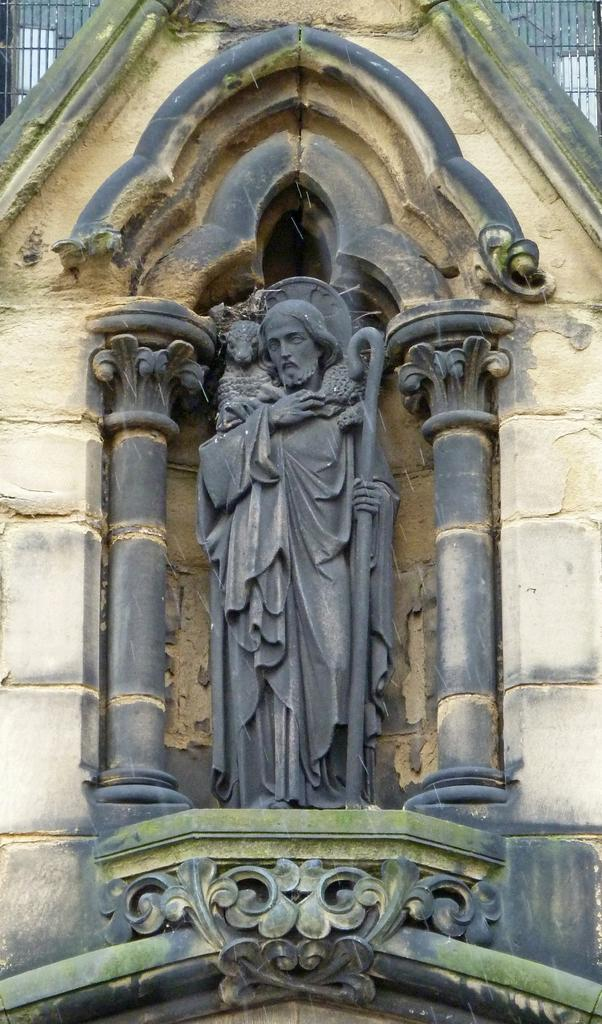What is the main subject of the image? There is a statue of Jesus in the image. What type of hammer is being used to tie a knot in the sheet in the image? There is no hammer, sheet, or knot present in the image; it only features a statue of Jesus. 